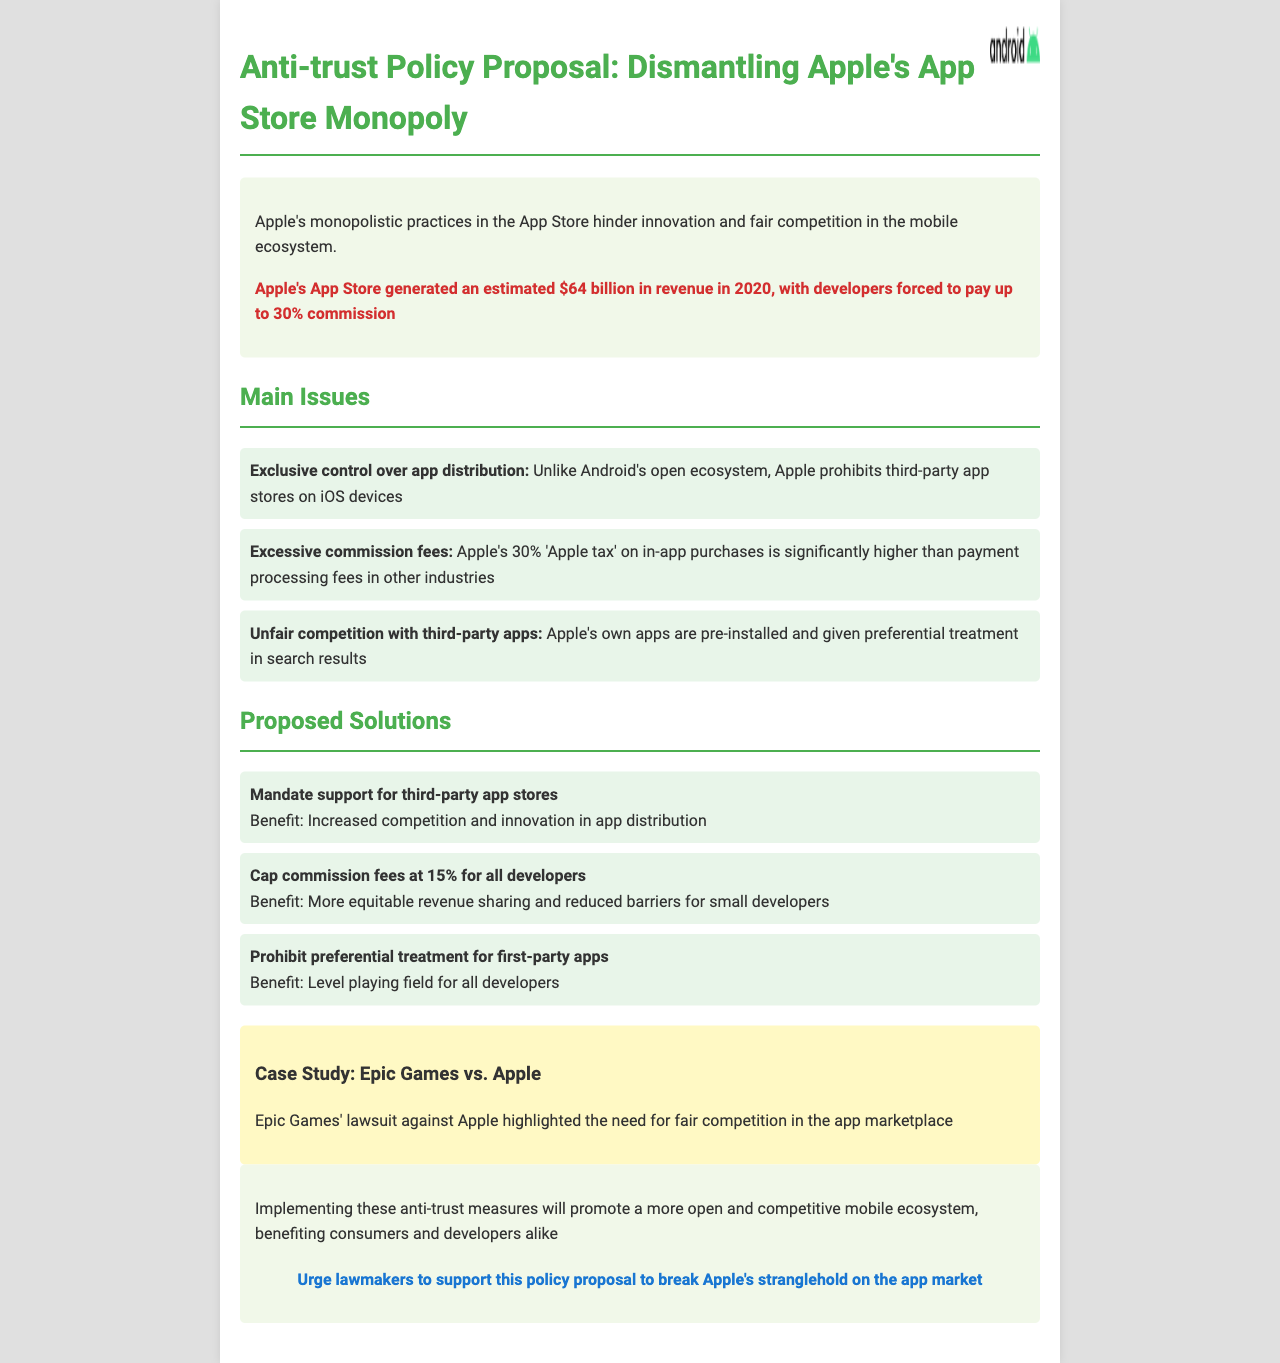What is the title of the proposal? The title of the proposal is located at the top of the document and states the focus of the proposal.
Answer: Anti-trust Policy Proposal: Dismantling Apple's App Store Monopoly What percentage is referred to as the 'Apple tax'? The document specifies a percentage associated with Apple's fees imposed on developers, highlighting its impact.
Answer: 30% How much did Apple's App Store generate in revenue in 2020? The document provides a specific revenue figure for the year 2020, illustrating the scale of Apple's business.
Answer: $64 billion What is one proposed solution related to commission fees? The document lists several solutions, with one specifically addressing the commission structure imposed by Apple.
Answer: Cap commission fees at 15% for all developers What is the case study mentioned in the document? The document includes a specific legal case that exemplifies challenges in the app marketplace, relevant to the antitrust discussions.
Answer: Epic Games vs. Apple What main issue relates to app distribution on iOS? The document identifies a significant problem concerning the distribution of applications within the Apple ecosystem.
Answer: Exclusive control over app distribution What kind of treatment is proposed to be prohibited for first-party apps? The objectives of the proposal include addressing certain preferential practices that may harm competition.
Answer: Prohibit preferential treatment for first-party apps What is a benefit of mandating third-party app store support? The document outlines expected advantages of implementing a particular solution that would promote competition.
Answer: Increased competition and innovation in app distribution 